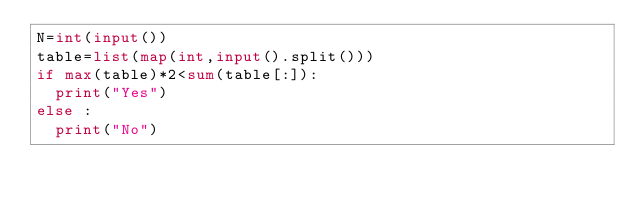<code> <loc_0><loc_0><loc_500><loc_500><_Python_>N=int(input())
table=list(map(int,input().split()))
if max(table)*2<sum(table[:]):
  print("Yes")
else :
  print("No")</code> 